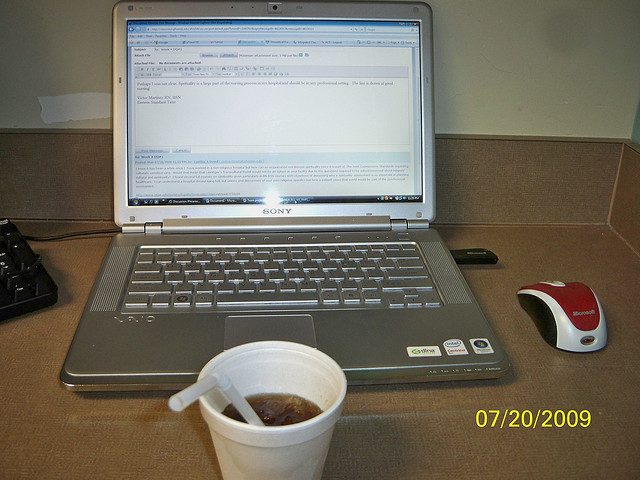<image>What ad is on the mouse pad? There is no ad on the mouse pad. However, it might be Microsoft or HP. What ad is on the mouse pad? There isn't an ad on the mouse pad. 